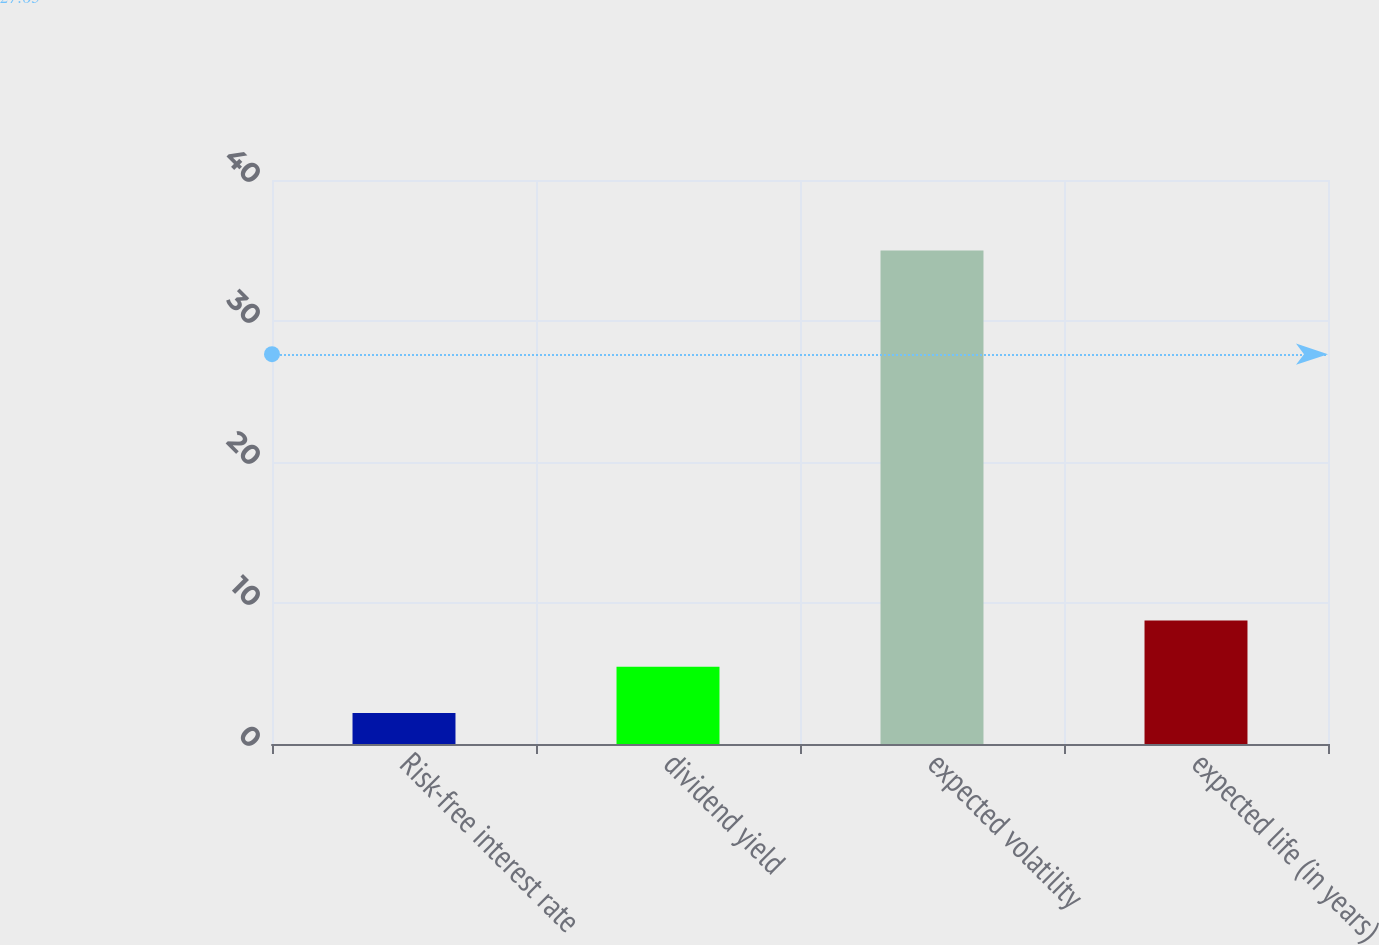Convert chart to OTSL. <chart><loc_0><loc_0><loc_500><loc_500><bar_chart><fcel>Risk-free interest rate<fcel>dividend yield<fcel>expected volatility<fcel>expected life (in years)<nl><fcel>2.2<fcel>5.48<fcel>35<fcel>8.76<nl></chart> 